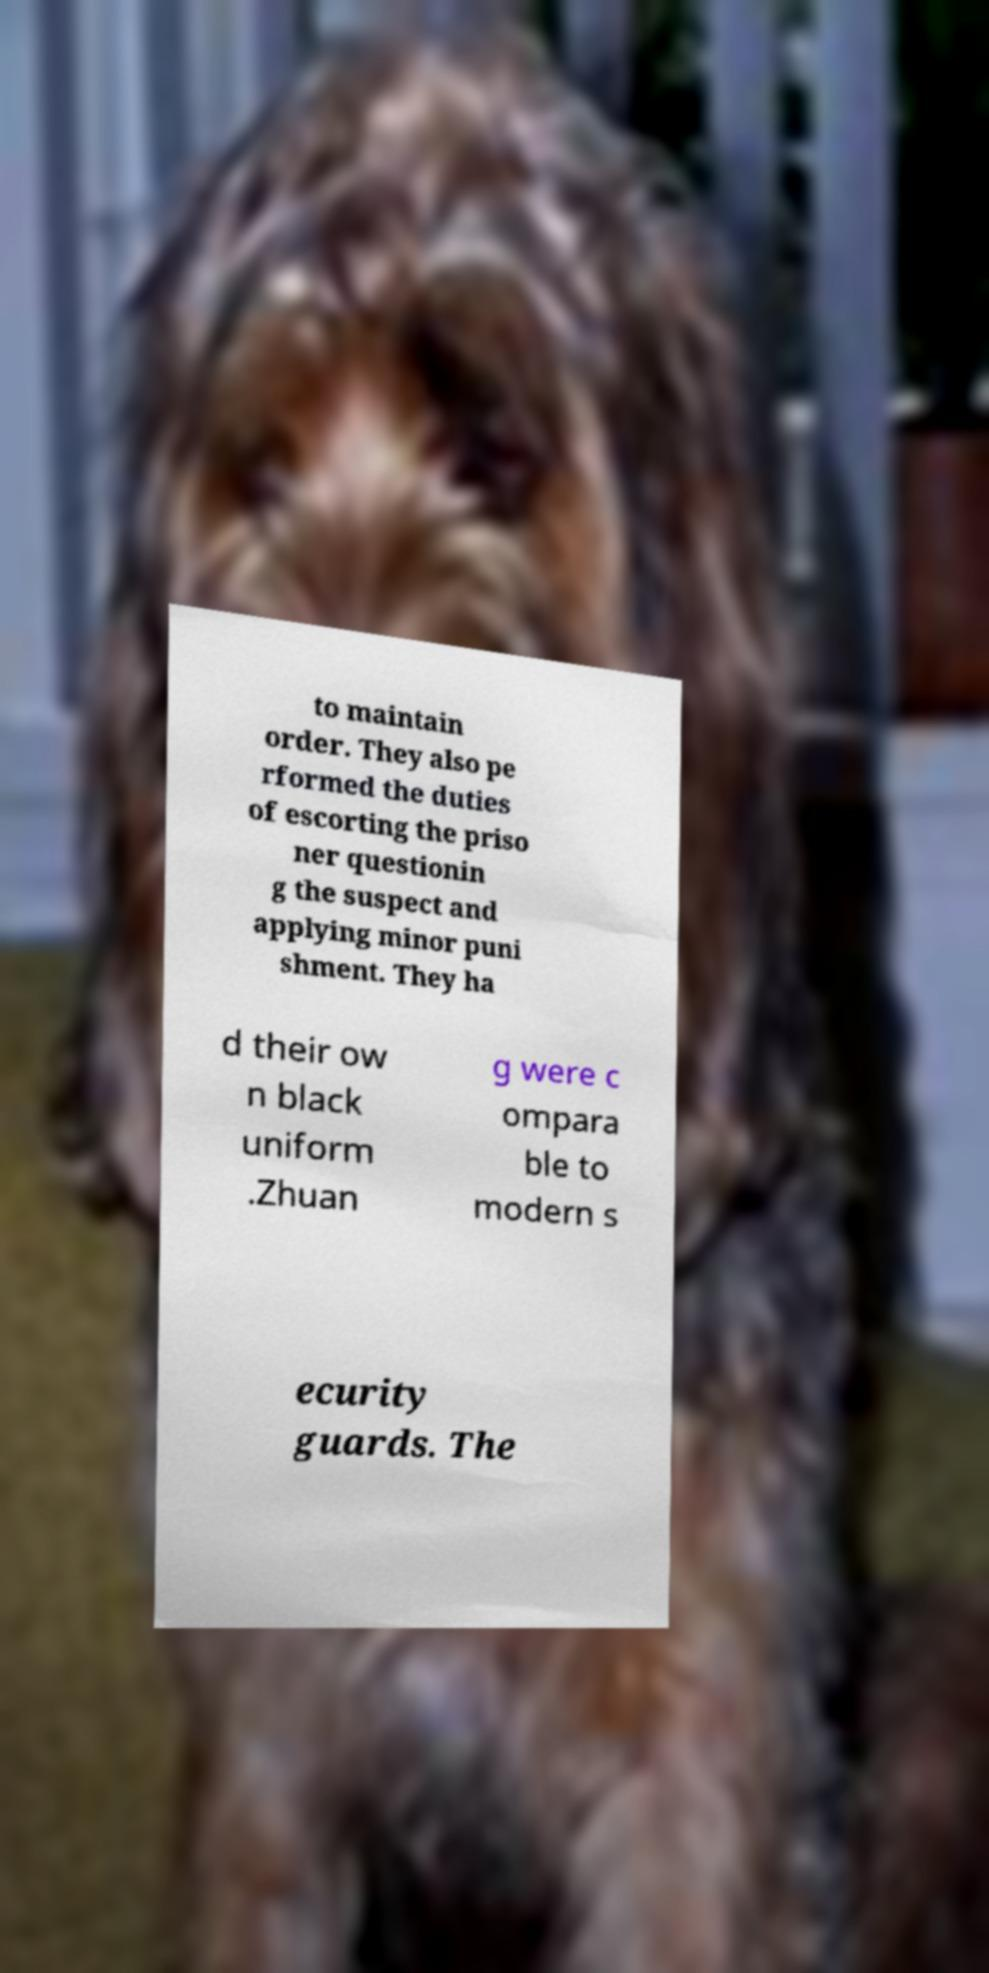Could you extract and type out the text from this image? to maintain order. They also pe rformed the duties of escorting the priso ner questionin g the suspect and applying minor puni shment. They ha d their ow n black uniform .Zhuan g were c ompara ble to modern s ecurity guards. The 